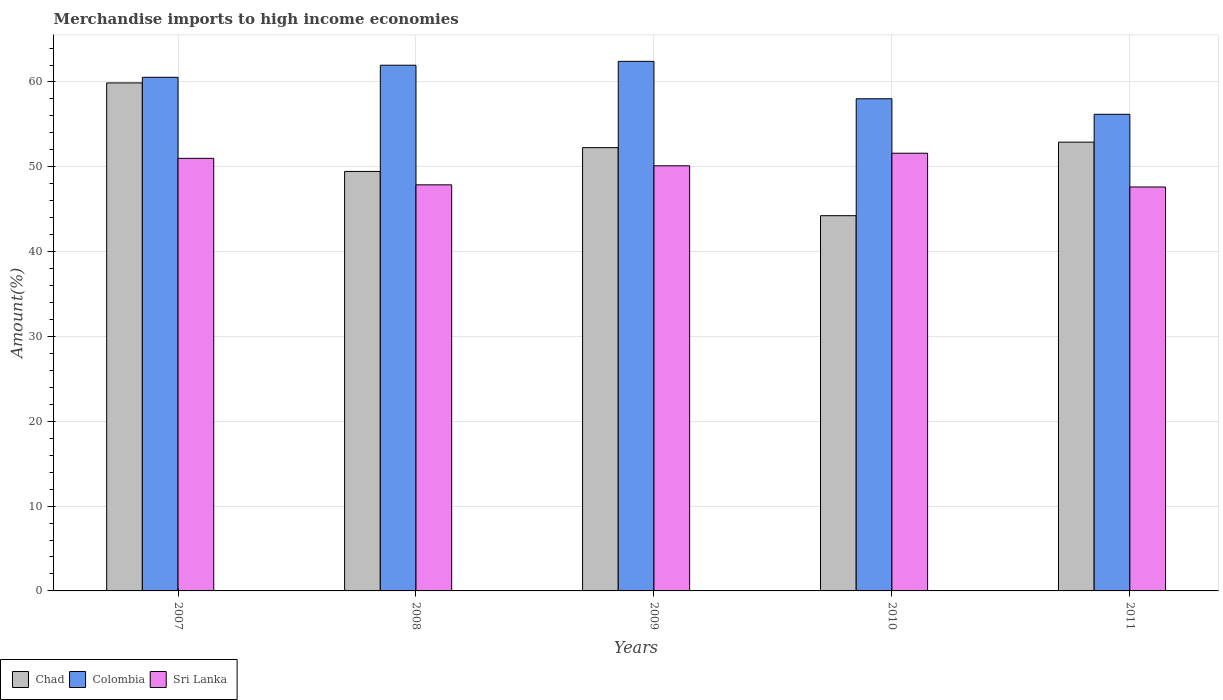How many groups of bars are there?
Ensure brevity in your answer.  5. How many bars are there on the 2nd tick from the left?
Offer a very short reply. 3. What is the label of the 4th group of bars from the left?
Give a very brief answer. 2010. In how many cases, is the number of bars for a given year not equal to the number of legend labels?
Provide a succinct answer. 0. What is the percentage of amount earned from merchandise imports in Sri Lanka in 2008?
Your answer should be very brief. 47.87. Across all years, what is the maximum percentage of amount earned from merchandise imports in Sri Lanka?
Your response must be concise. 51.6. Across all years, what is the minimum percentage of amount earned from merchandise imports in Chad?
Offer a very short reply. 44.24. In which year was the percentage of amount earned from merchandise imports in Colombia maximum?
Provide a succinct answer. 2009. In which year was the percentage of amount earned from merchandise imports in Colombia minimum?
Provide a short and direct response. 2011. What is the total percentage of amount earned from merchandise imports in Colombia in the graph?
Give a very brief answer. 299.16. What is the difference between the percentage of amount earned from merchandise imports in Sri Lanka in 2007 and that in 2010?
Your answer should be very brief. -0.6. What is the difference between the percentage of amount earned from merchandise imports in Colombia in 2008 and the percentage of amount earned from merchandise imports in Sri Lanka in 2010?
Offer a terse response. 10.37. What is the average percentage of amount earned from merchandise imports in Colombia per year?
Your answer should be very brief. 59.83. In the year 2010, what is the difference between the percentage of amount earned from merchandise imports in Chad and percentage of amount earned from merchandise imports in Colombia?
Provide a succinct answer. -13.78. In how many years, is the percentage of amount earned from merchandise imports in Sri Lanka greater than 10 %?
Keep it short and to the point. 5. What is the ratio of the percentage of amount earned from merchandise imports in Chad in 2008 to that in 2010?
Offer a terse response. 1.12. Is the difference between the percentage of amount earned from merchandise imports in Chad in 2008 and 2009 greater than the difference between the percentage of amount earned from merchandise imports in Colombia in 2008 and 2009?
Make the answer very short. No. What is the difference between the highest and the second highest percentage of amount earned from merchandise imports in Colombia?
Your answer should be compact. 0.46. What is the difference between the highest and the lowest percentage of amount earned from merchandise imports in Chad?
Provide a short and direct response. 15.65. In how many years, is the percentage of amount earned from merchandise imports in Chad greater than the average percentage of amount earned from merchandise imports in Chad taken over all years?
Offer a terse response. 3. What does the 1st bar from the left in 2008 represents?
Make the answer very short. Chad. What does the 2nd bar from the right in 2008 represents?
Your response must be concise. Colombia. Is it the case that in every year, the sum of the percentage of amount earned from merchandise imports in Colombia and percentage of amount earned from merchandise imports in Chad is greater than the percentage of amount earned from merchandise imports in Sri Lanka?
Offer a very short reply. Yes. How many years are there in the graph?
Your answer should be very brief. 5. What is the difference between two consecutive major ticks on the Y-axis?
Your response must be concise. 10. Does the graph contain any zero values?
Make the answer very short. No. Does the graph contain grids?
Make the answer very short. Yes. Where does the legend appear in the graph?
Your answer should be compact. Bottom left. How many legend labels are there?
Make the answer very short. 3. How are the legend labels stacked?
Offer a very short reply. Horizontal. What is the title of the graph?
Provide a short and direct response. Merchandise imports to high income economies. What is the label or title of the X-axis?
Ensure brevity in your answer.  Years. What is the label or title of the Y-axis?
Your response must be concise. Amount(%). What is the Amount(%) in Chad in 2007?
Your answer should be very brief. 59.89. What is the Amount(%) in Colombia in 2007?
Your answer should be compact. 60.55. What is the Amount(%) of Sri Lanka in 2007?
Ensure brevity in your answer.  51. What is the Amount(%) in Chad in 2008?
Your answer should be compact. 49.45. What is the Amount(%) of Colombia in 2008?
Provide a short and direct response. 61.97. What is the Amount(%) in Sri Lanka in 2008?
Your response must be concise. 47.87. What is the Amount(%) in Chad in 2009?
Your answer should be compact. 52.26. What is the Amount(%) of Colombia in 2009?
Ensure brevity in your answer.  62.43. What is the Amount(%) of Sri Lanka in 2009?
Provide a succinct answer. 50.12. What is the Amount(%) of Chad in 2010?
Your answer should be compact. 44.24. What is the Amount(%) of Colombia in 2010?
Keep it short and to the point. 58.02. What is the Amount(%) of Sri Lanka in 2010?
Ensure brevity in your answer.  51.6. What is the Amount(%) of Chad in 2011?
Your response must be concise. 52.91. What is the Amount(%) in Colombia in 2011?
Your answer should be compact. 56.19. What is the Amount(%) of Sri Lanka in 2011?
Keep it short and to the point. 47.62. Across all years, what is the maximum Amount(%) in Chad?
Offer a terse response. 59.89. Across all years, what is the maximum Amount(%) of Colombia?
Your answer should be very brief. 62.43. Across all years, what is the maximum Amount(%) of Sri Lanka?
Offer a very short reply. 51.6. Across all years, what is the minimum Amount(%) in Chad?
Give a very brief answer. 44.24. Across all years, what is the minimum Amount(%) of Colombia?
Your response must be concise. 56.19. Across all years, what is the minimum Amount(%) in Sri Lanka?
Provide a succinct answer. 47.62. What is the total Amount(%) of Chad in the graph?
Offer a terse response. 258.74. What is the total Amount(%) in Colombia in the graph?
Your answer should be very brief. 299.16. What is the total Amount(%) of Sri Lanka in the graph?
Provide a short and direct response. 248.2. What is the difference between the Amount(%) in Chad in 2007 and that in 2008?
Ensure brevity in your answer.  10.43. What is the difference between the Amount(%) in Colombia in 2007 and that in 2008?
Your response must be concise. -1.43. What is the difference between the Amount(%) in Sri Lanka in 2007 and that in 2008?
Offer a very short reply. 3.12. What is the difference between the Amount(%) of Chad in 2007 and that in 2009?
Ensure brevity in your answer.  7.63. What is the difference between the Amount(%) of Colombia in 2007 and that in 2009?
Give a very brief answer. -1.88. What is the difference between the Amount(%) in Sri Lanka in 2007 and that in 2009?
Offer a terse response. 0.88. What is the difference between the Amount(%) of Chad in 2007 and that in 2010?
Offer a very short reply. 15.65. What is the difference between the Amount(%) of Colombia in 2007 and that in 2010?
Offer a terse response. 2.53. What is the difference between the Amount(%) of Sri Lanka in 2007 and that in 2010?
Your answer should be very brief. -0.6. What is the difference between the Amount(%) of Chad in 2007 and that in 2011?
Your response must be concise. 6.98. What is the difference between the Amount(%) in Colombia in 2007 and that in 2011?
Your response must be concise. 4.36. What is the difference between the Amount(%) of Sri Lanka in 2007 and that in 2011?
Give a very brief answer. 3.38. What is the difference between the Amount(%) of Chad in 2008 and that in 2009?
Your answer should be compact. -2.8. What is the difference between the Amount(%) in Colombia in 2008 and that in 2009?
Provide a short and direct response. -0.46. What is the difference between the Amount(%) of Sri Lanka in 2008 and that in 2009?
Provide a succinct answer. -2.24. What is the difference between the Amount(%) in Chad in 2008 and that in 2010?
Give a very brief answer. 5.22. What is the difference between the Amount(%) of Colombia in 2008 and that in 2010?
Provide a succinct answer. 3.95. What is the difference between the Amount(%) of Sri Lanka in 2008 and that in 2010?
Your answer should be compact. -3.73. What is the difference between the Amount(%) of Chad in 2008 and that in 2011?
Provide a short and direct response. -3.45. What is the difference between the Amount(%) in Colombia in 2008 and that in 2011?
Ensure brevity in your answer.  5.78. What is the difference between the Amount(%) in Sri Lanka in 2008 and that in 2011?
Your answer should be compact. 0.25. What is the difference between the Amount(%) of Chad in 2009 and that in 2010?
Keep it short and to the point. 8.02. What is the difference between the Amount(%) in Colombia in 2009 and that in 2010?
Provide a short and direct response. 4.41. What is the difference between the Amount(%) in Sri Lanka in 2009 and that in 2010?
Your answer should be very brief. -1.48. What is the difference between the Amount(%) in Chad in 2009 and that in 2011?
Give a very brief answer. -0.65. What is the difference between the Amount(%) of Colombia in 2009 and that in 2011?
Your response must be concise. 6.24. What is the difference between the Amount(%) of Sri Lanka in 2009 and that in 2011?
Offer a very short reply. 2.5. What is the difference between the Amount(%) in Chad in 2010 and that in 2011?
Provide a short and direct response. -8.67. What is the difference between the Amount(%) of Colombia in 2010 and that in 2011?
Make the answer very short. 1.83. What is the difference between the Amount(%) in Sri Lanka in 2010 and that in 2011?
Provide a succinct answer. 3.98. What is the difference between the Amount(%) of Chad in 2007 and the Amount(%) of Colombia in 2008?
Your answer should be very brief. -2.09. What is the difference between the Amount(%) in Chad in 2007 and the Amount(%) in Sri Lanka in 2008?
Offer a very short reply. 12.01. What is the difference between the Amount(%) in Colombia in 2007 and the Amount(%) in Sri Lanka in 2008?
Keep it short and to the point. 12.68. What is the difference between the Amount(%) of Chad in 2007 and the Amount(%) of Colombia in 2009?
Your answer should be very brief. -2.54. What is the difference between the Amount(%) of Chad in 2007 and the Amount(%) of Sri Lanka in 2009?
Your answer should be compact. 9.77. What is the difference between the Amount(%) in Colombia in 2007 and the Amount(%) in Sri Lanka in 2009?
Offer a very short reply. 10.43. What is the difference between the Amount(%) in Chad in 2007 and the Amount(%) in Colombia in 2010?
Provide a short and direct response. 1.87. What is the difference between the Amount(%) of Chad in 2007 and the Amount(%) of Sri Lanka in 2010?
Ensure brevity in your answer.  8.29. What is the difference between the Amount(%) of Colombia in 2007 and the Amount(%) of Sri Lanka in 2010?
Offer a very short reply. 8.95. What is the difference between the Amount(%) in Chad in 2007 and the Amount(%) in Colombia in 2011?
Give a very brief answer. 3.7. What is the difference between the Amount(%) of Chad in 2007 and the Amount(%) of Sri Lanka in 2011?
Your answer should be very brief. 12.27. What is the difference between the Amount(%) in Colombia in 2007 and the Amount(%) in Sri Lanka in 2011?
Keep it short and to the point. 12.93. What is the difference between the Amount(%) of Chad in 2008 and the Amount(%) of Colombia in 2009?
Ensure brevity in your answer.  -12.98. What is the difference between the Amount(%) of Chad in 2008 and the Amount(%) of Sri Lanka in 2009?
Make the answer very short. -0.66. What is the difference between the Amount(%) in Colombia in 2008 and the Amount(%) in Sri Lanka in 2009?
Your answer should be very brief. 11.86. What is the difference between the Amount(%) of Chad in 2008 and the Amount(%) of Colombia in 2010?
Your response must be concise. -8.57. What is the difference between the Amount(%) in Chad in 2008 and the Amount(%) in Sri Lanka in 2010?
Ensure brevity in your answer.  -2.15. What is the difference between the Amount(%) of Colombia in 2008 and the Amount(%) of Sri Lanka in 2010?
Make the answer very short. 10.37. What is the difference between the Amount(%) of Chad in 2008 and the Amount(%) of Colombia in 2011?
Ensure brevity in your answer.  -6.74. What is the difference between the Amount(%) in Chad in 2008 and the Amount(%) in Sri Lanka in 2011?
Your answer should be very brief. 1.84. What is the difference between the Amount(%) in Colombia in 2008 and the Amount(%) in Sri Lanka in 2011?
Your answer should be compact. 14.36. What is the difference between the Amount(%) of Chad in 2009 and the Amount(%) of Colombia in 2010?
Offer a terse response. -5.76. What is the difference between the Amount(%) of Chad in 2009 and the Amount(%) of Sri Lanka in 2010?
Ensure brevity in your answer.  0.66. What is the difference between the Amount(%) in Colombia in 2009 and the Amount(%) in Sri Lanka in 2010?
Ensure brevity in your answer.  10.83. What is the difference between the Amount(%) in Chad in 2009 and the Amount(%) in Colombia in 2011?
Your answer should be compact. -3.93. What is the difference between the Amount(%) in Chad in 2009 and the Amount(%) in Sri Lanka in 2011?
Your answer should be compact. 4.64. What is the difference between the Amount(%) of Colombia in 2009 and the Amount(%) of Sri Lanka in 2011?
Make the answer very short. 14.81. What is the difference between the Amount(%) in Chad in 2010 and the Amount(%) in Colombia in 2011?
Keep it short and to the point. -11.95. What is the difference between the Amount(%) of Chad in 2010 and the Amount(%) of Sri Lanka in 2011?
Offer a terse response. -3.38. What is the difference between the Amount(%) in Colombia in 2010 and the Amount(%) in Sri Lanka in 2011?
Provide a succinct answer. 10.4. What is the average Amount(%) of Chad per year?
Offer a very short reply. 51.75. What is the average Amount(%) of Colombia per year?
Your answer should be very brief. 59.83. What is the average Amount(%) in Sri Lanka per year?
Your answer should be compact. 49.64. In the year 2007, what is the difference between the Amount(%) in Chad and Amount(%) in Colombia?
Provide a succinct answer. -0.66. In the year 2007, what is the difference between the Amount(%) of Chad and Amount(%) of Sri Lanka?
Offer a very short reply. 8.89. In the year 2007, what is the difference between the Amount(%) of Colombia and Amount(%) of Sri Lanka?
Ensure brevity in your answer.  9.55. In the year 2008, what is the difference between the Amount(%) of Chad and Amount(%) of Colombia?
Ensure brevity in your answer.  -12.52. In the year 2008, what is the difference between the Amount(%) of Chad and Amount(%) of Sri Lanka?
Give a very brief answer. 1.58. In the year 2008, what is the difference between the Amount(%) in Colombia and Amount(%) in Sri Lanka?
Your response must be concise. 14.1. In the year 2009, what is the difference between the Amount(%) of Chad and Amount(%) of Colombia?
Give a very brief answer. -10.17. In the year 2009, what is the difference between the Amount(%) in Chad and Amount(%) in Sri Lanka?
Your response must be concise. 2.14. In the year 2009, what is the difference between the Amount(%) of Colombia and Amount(%) of Sri Lanka?
Ensure brevity in your answer.  12.31. In the year 2010, what is the difference between the Amount(%) of Chad and Amount(%) of Colombia?
Your answer should be very brief. -13.78. In the year 2010, what is the difference between the Amount(%) of Chad and Amount(%) of Sri Lanka?
Your response must be concise. -7.36. In the year 2010, what is the difference between the Amount(%) in Colombia and Amount(%) in Sri Lanka?
Keep it short and to the point. 6.42. In the year 2011, what is the difference between the Amount(%) of Chad and Amount(%) of Colombia?
Your answer should be compact. -3.28. In the year 2011, what is the difference between the Amount(%) of Chad and Amount(%) of Sri Lanka?
Offer a terse response. 5.29. In the year 2011, what is the difference between the Amount(%) of Colombia and Amount(%) of Sri Lanka?
Offer a terse response. 8.57. What is the ratio of the Amount(%) of Chad in 2007 to that in 2008?
Offer a very short reply. 1.21. What is the ratio of the Amount(%) in Sri Lanka in 2007 to that in 2008?
Make the answer very short. 1.07. What is the ratio of the Amount(%) of Chad in 2007 to that in 2009?
Provide a short and direct response. 1.15. What is the ratio of the Amount(%) in Colombia in 2007 to that in 2009?
Make the answer very short. 0.97. What is the ratio of the Amount(%) in Sri Lanka in 2007 to that in 2009?
Your response must be concise. 1.02. What is the ratio of the Amount(%) of Chad in 2007 to that in 2010?
Ensure brevity in your answer.  1.35. What is the ratio of the Amount(%) in Colombia in 2007 to that in 2010?
Give a very brief answer. 1.04. What is the ratio of the Amount(%) in Sri Lanka in 2007 to that in 2010?
Provide a succinct answer. 0.99. What is the ratio of the Amount(%) in Chad in 2007 to that in 2011?
Give a very brief answer. 1.13. What is the ratio of the Amount(%) in Colombia in 2007 to that in 2011?
Your answer should be compact. 1.08. What is the ratio of the Amount(%) in Sri Lanka in 2007 to that in 2011?
Your answer should be very brief. 1.07. What is the ratio of the Amount(%) in Chad in 2008 to that in 2009?
Offer a very short reply. 0.95. What is the ratio of the Amount(%) of Sri Lanka in 2008 to that in 2009?
Give a very brief answer. 0.96. What is the ratio of the Amount(%) in Chad in 2008 to that in 2010?
Provide a succinct answer. 1.12. What is the ratio of the Amount(%) of Colombia in 2008 to that in 2010?
Provide a short and direct response. 1.07. What is the ratio of the Amount(%) of Sri Lanka in 2008 to that in 2010?
Make the answer very short. 0.93. What is the ratio of the Amount(%) of Chad in 2008 to that in 2011?
Offer a very short reply. 0.93. What is the ratio of the Amount(%) in Colombia in 2008 to that in 2011?
Ensure brevity in your answer.  1.1. What is the ratio of the Amount(%) of Sri Lanka in 2008 to that in 2011?
Your response must be concise. 1.01. What is the ratio of the Amount(%) in Chad in 2009 to that in 2010?
Ensure brevity in your answer.  1.18. What is the ratio of the Amount(%) in Colombia in 2009 to that in 2010?
Give a very brief answer. 1.08. What is the ratio of the Amount(%) in Sri Lanka in 2009 to that in 2010?
Your response must be concise. 0.97. What is the ratio of the Amount(%) in Colombia in 2009 to that in 2011?
Your response must be concise. 1.11. What is the ratio of the Amount(%) in Sri Lanka in 2009 to that in 2011?
Ensure brevity in your answer.  1.05. What is the ratio of the Amount(%) in Chad in 2010 to that in 2011?
Your answer should be very brief. 0.84. What is the ratio of the Amount(%) of Colombia in 2010 to that in 2011?
Make the answer very short. 1.03. What is the ratio of the Amount(%) in Sri Lanka in 2010 to that in 2011?
Offer a very short reply. 1.08. What is the difference between the highest and the second highest Amount(%) of Chad?
Your answer should be compact. 6.98. What is the difference between the highest and the second highest Amount(%) in Colombia?
Give a very brief answer. 0.46. What is the difference between the highest and the second highest Amount(%) of Sri Lanka?
Offer a terse response. 0.6. What is the difference between the highest and the lowest Amount(%) in Chad?
Ensure brevity in your answer.  15.65. What is the difference between the highest and the lowest Amount(%) in Colombia?
Provide a short and direct response. 6.24. What is the difference between the highest and the lowest Amount(%) in Sri Lanka?
Your answer should be very brief. 3.98. 